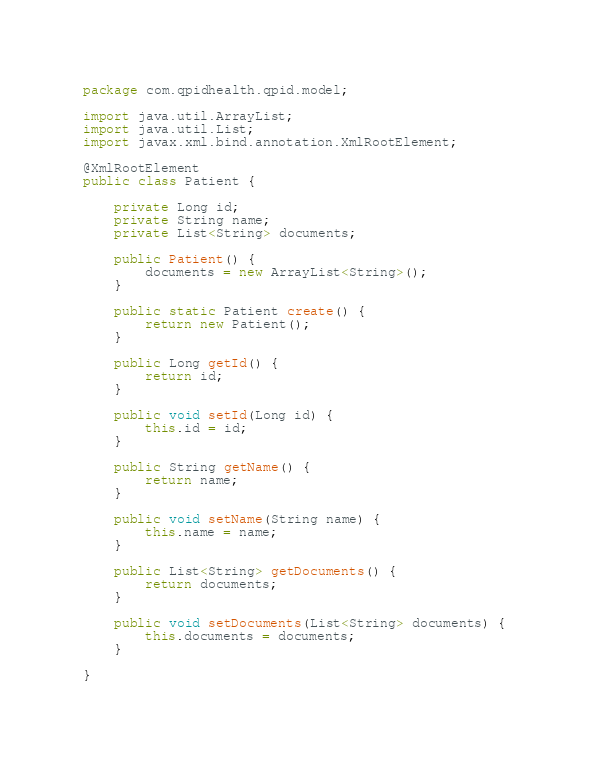Convert code to text. <code><loc_0><loc_0><loc_500><loc_500><_Java_>package com.qpidhealth.qpid.model;

import java.util.ArrayList;
import java.util.List;
import javax.xml.bind.annotation.XmlRootElement;

@XmlRootElement
public class Patient {

	private Long id;
	private String name;
	private List<String> documents;

	public Patient() {
		documents = new ArrayList<String>();
	}

	public static Patient create() {
		return new Patient();
	}

	public Long getId() {
		return id;
	}

	public void setId(Long id) {
		this.id = id;
	}

	public String getName() {
		return name;
	}

	public void setName(String name) {
		this.name = name;
	}

	public List<String> getDocuments() {
		return documents;
	}

	public void setDocuments(List<String> documents) {
		this.documents = documents;
	}

}
</code> 